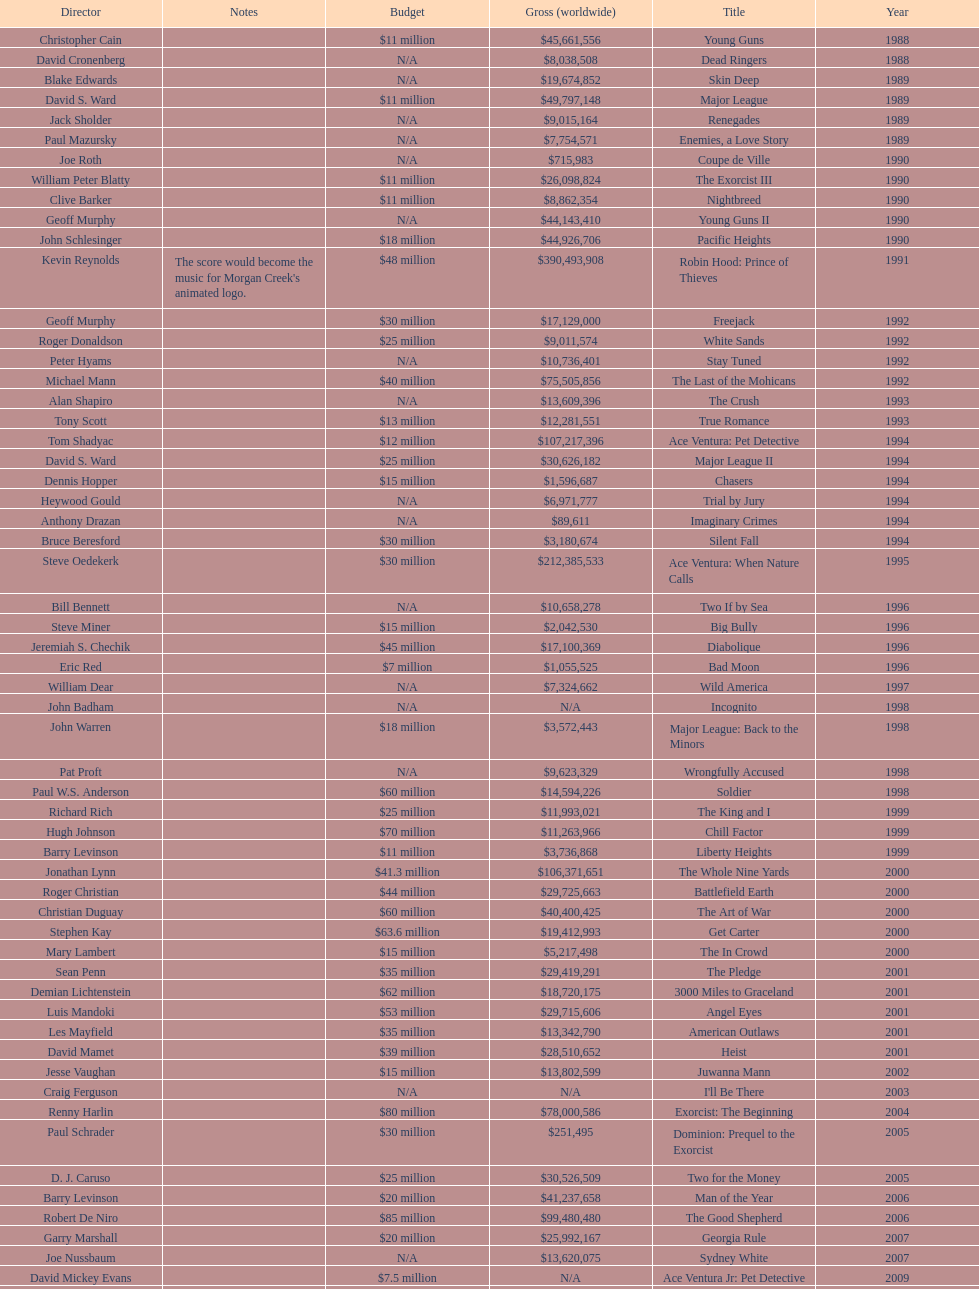What is the top grossing film? Robin Hood: Prince of Thieves. 